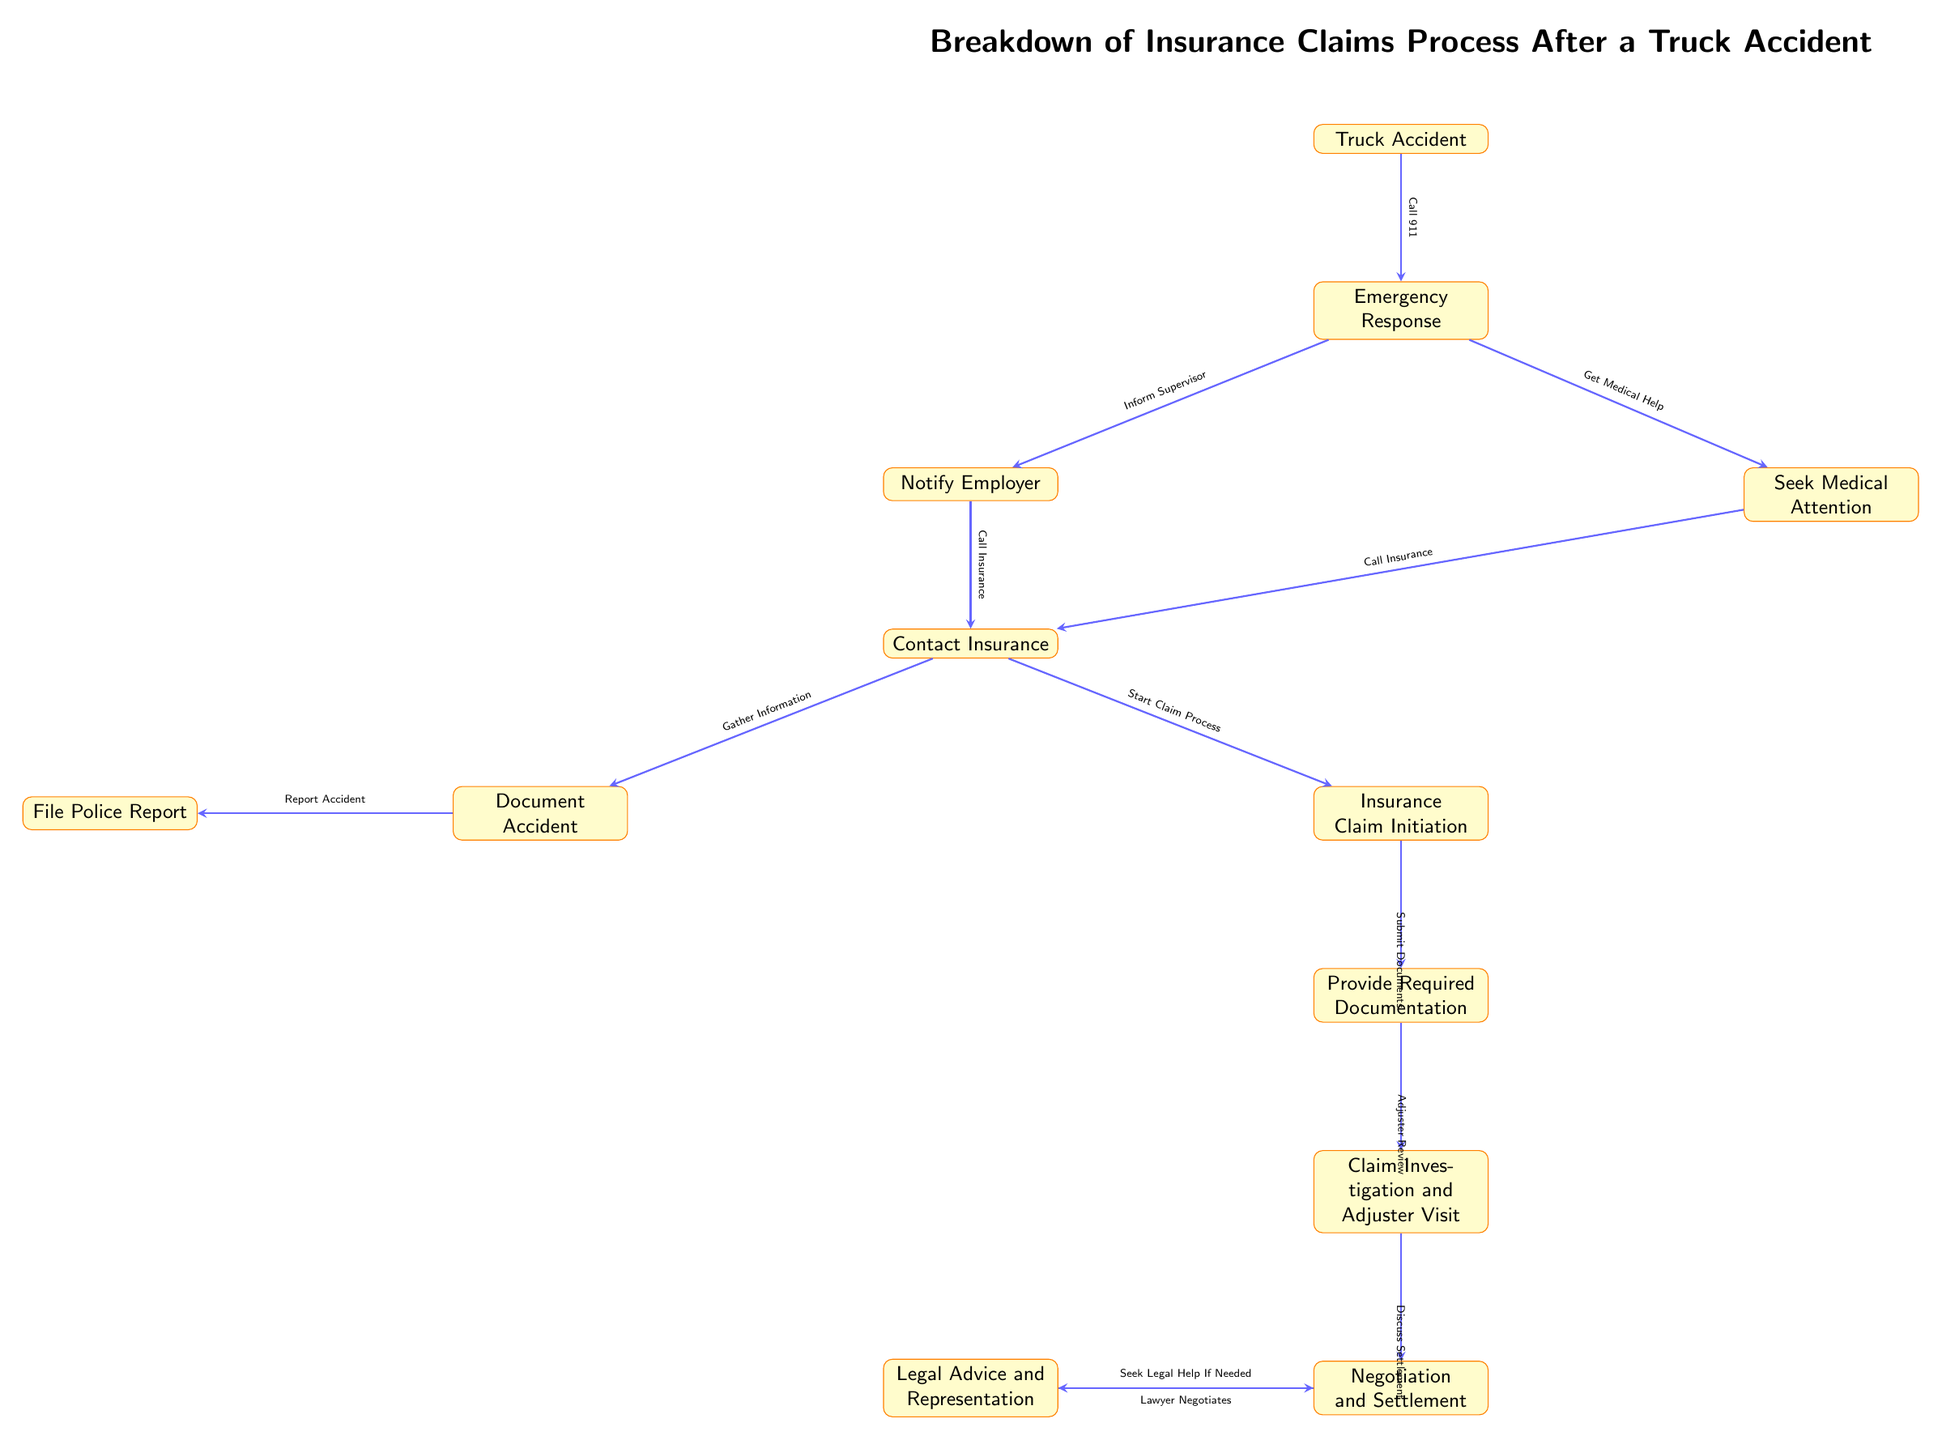What is the first step after the truck accident? The diagram indicates that the first step after a truck accident is "Emergency Response," which follows directly after the incident. This is shown as the node directly below "Truck Accident."
Answer: Emergency Response How many main steps are there in this insurance claims process? By counting the nodes that represent steps in the process, there are a total of 11 main steps, starting from "Truck Accident" and ending with "Negotiation and Settlement."
Answer: 11 Which node follows "Contact Insurance"? After "Contact Insurance," the next step is "Document Accident," as shown in the flowchart where an arrow directly connects these two nodes.
Answer: Document Accident What is required after "Insurance Claim Initiation"? The flowchart shows that after "Insurance Claim Initiation," one must "Provide Required Documentation." This is indicated by the direct connection from one node to the next.
Answer: Provide Required Documentation What action should be taken if legal help is needed? The diagram states that one should "Seek Legal Help If Needed" after the "Negotiation and Settlement" phase, indicating this step can follow if the negotiation doesn't reach a satisfactory settlement.
Answer: Seek Legal Help If Needed How is the "Police Report" documented according to the flowchart? The diagram illustrates that the "Police Report" is documented after "Document Accident," which is connected to it via an arrow. It shows that producing a police report is an integral part of documenting the accident.
Answer: Report Accident Which two steps can take place simultaneously after Emergency Response? The flowchart indicates that "Notify Employer" and "Seek Medical Attention" are two steps that can occur simultaneously after the "Emergency Response," as they branch out from that node.
Answer: Notify Employer and Seek Medical Attention What is the overall purpose of the flowchart? The purpose of the flowchart is to outline the breakdown of the insurance claims process after a truck accident, visually representing the steps and documentation required to navigate the claims successfully.
Answer: Breakdown of Insurance Claims Process 